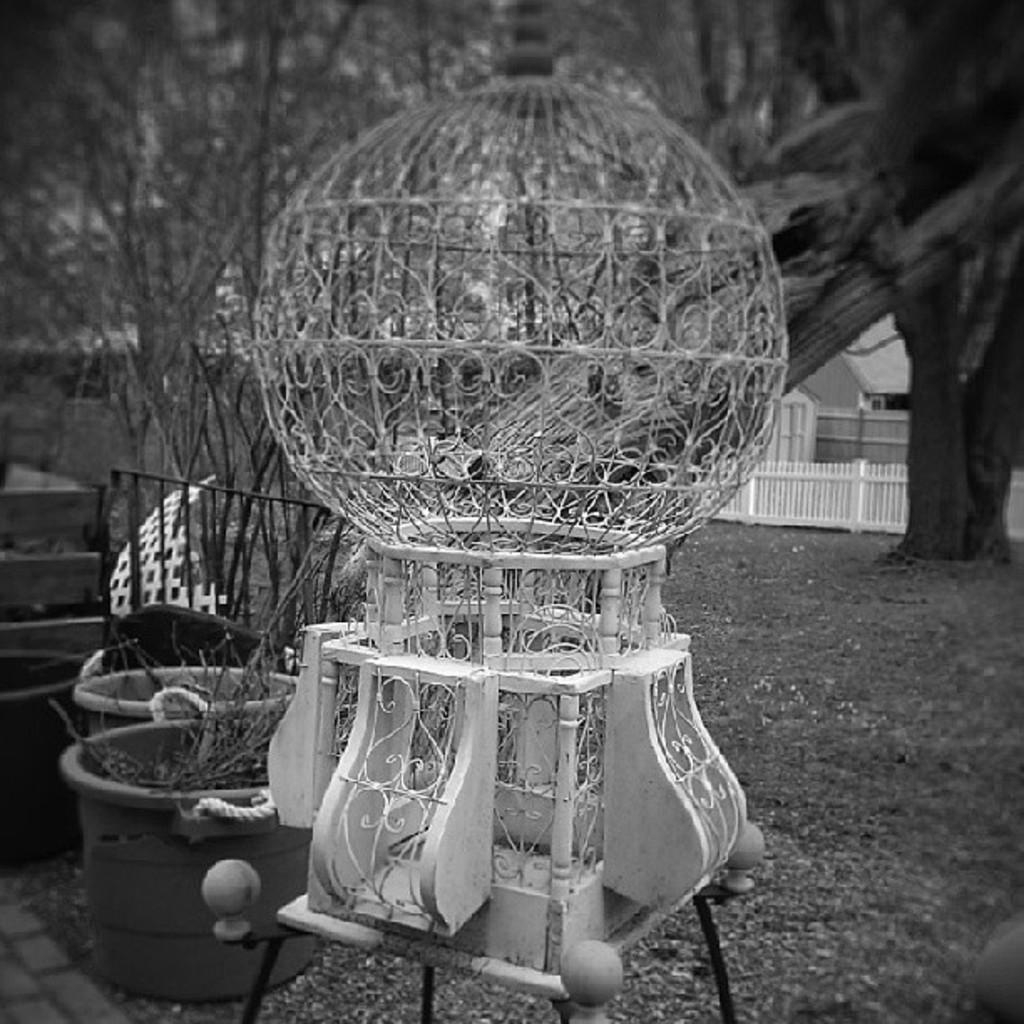How would you summarize this image in a sentence or two? This is the picture of a place where we have some trees, plants, fencing and a thing which is in white color on the table. 